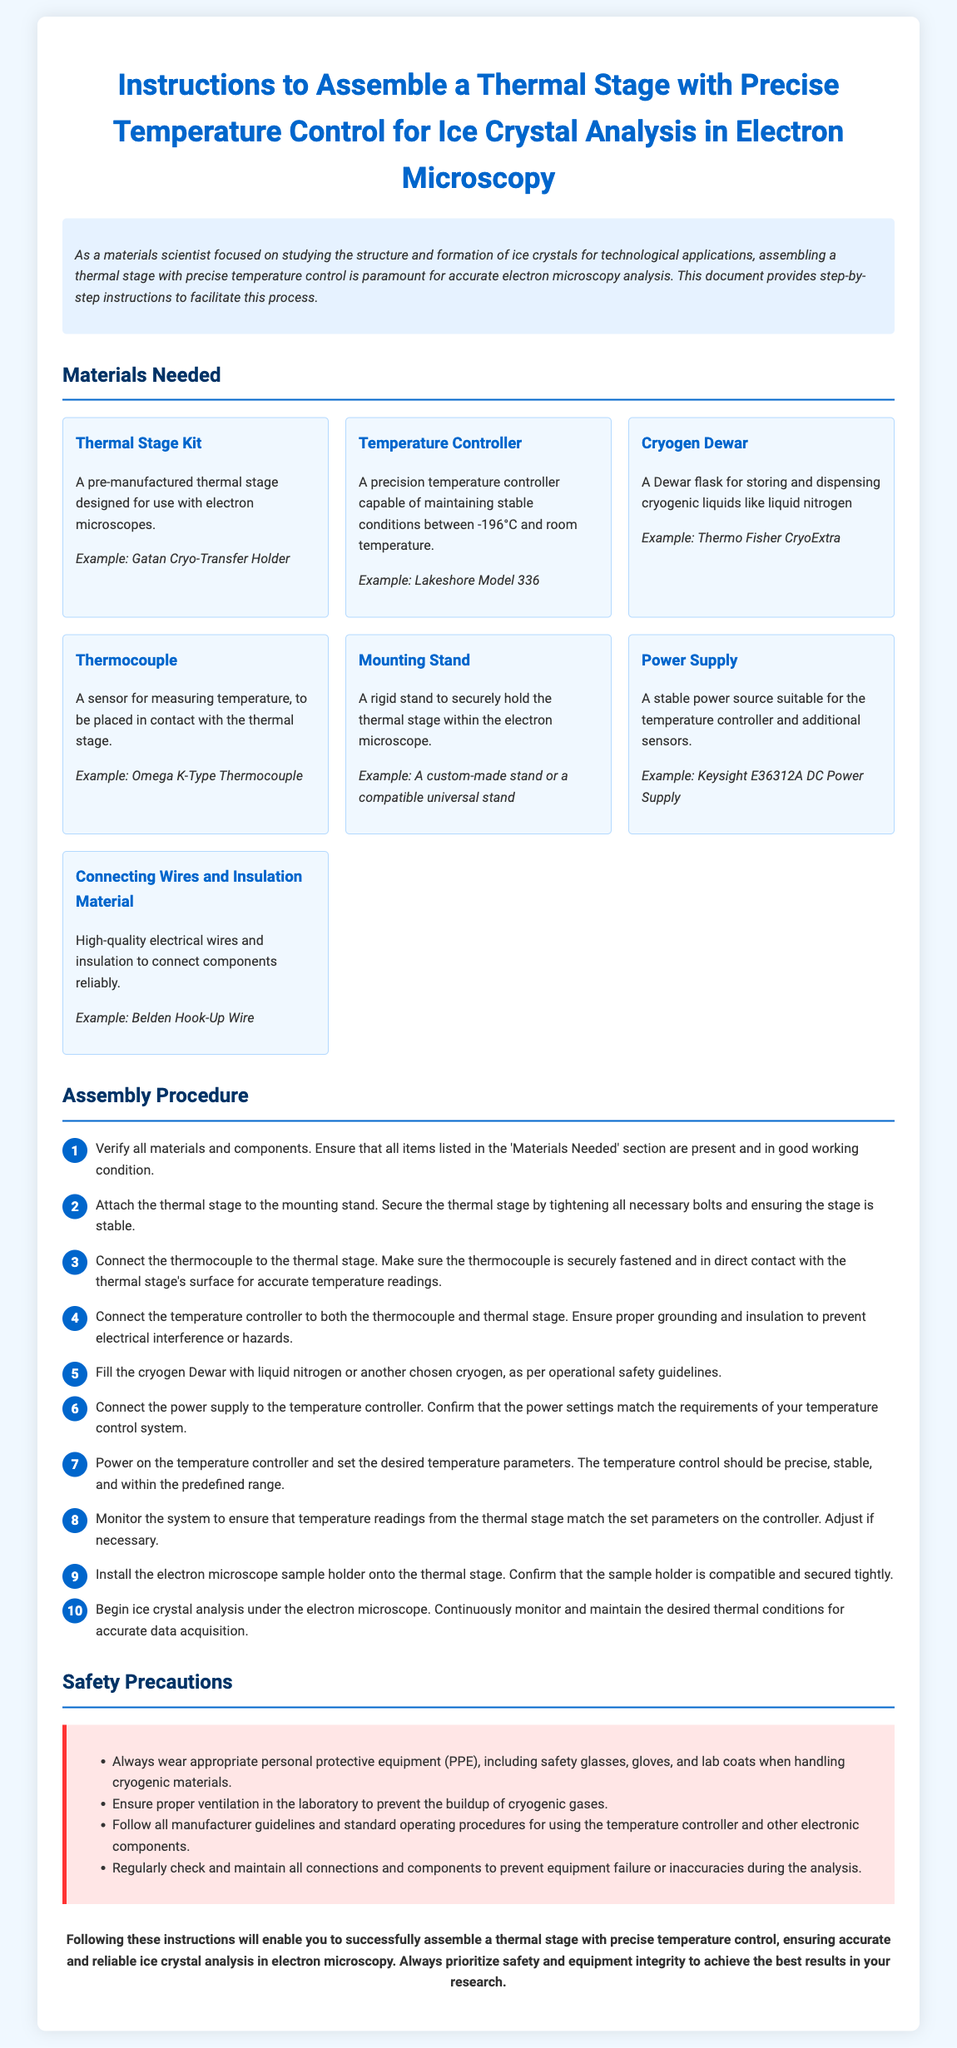what is the title of the document? The title is indicated at the top of the document and sets the main subject, which is about assembling a thermal stage for ice crystal analysis.
Answer: Instructions to Assemble a Thermal Stage with Precise Temperature Control for Ice Crystal Analysis in Electron Microscopy how many materials are listed in the document? The materials section lists seven distinct items needed for assembly, as evidenced in the materials needed section.
Answer: seven what is an example of a thermal stage kit mentioned? The document provides an example of a thermal stage kit, illustrating the type of thermal stage to be used in assembly.
Answer: Gatan Cryo-Transfer Holder what is the operating temperature range specified for the temperature controller? The operating temperature range for the temperature controller is explicitly mentioned in the materials section, which dictates its functionality.
Answer: -196°C to room temperature which safety equipment should be worn when handling cryogenic materials? The safety precautions highlight wearing equipment to ensure safety while handling materials, detailing personal protective gear.
Answer: safety glasses, gloves, and lab coats what step follows connecting the power supply to the temperature controller? The sequence of assembly steps is important for proper setup, detailing each required action in order.
Answer: Power on the temperature controller and set the desired temperature parameters how should the thermocouple be attached? The assembly instructions outline the specific method for attaching components to ensure accurate measurements, specifying attachment requirements.
Answer: securely fastened and in direct contact what is the first action to take in the assembly procedure? The initial step is crucial for ensuring that all necessary components are available before starting the assembly, as detailed in the instructions.
Answer: Verify all materials and components what document type is this text classified as? The content serves a specific purpose in guiding users through a complex process, classifying it under a specific genre of documents.
Answer: Assembly instructions 